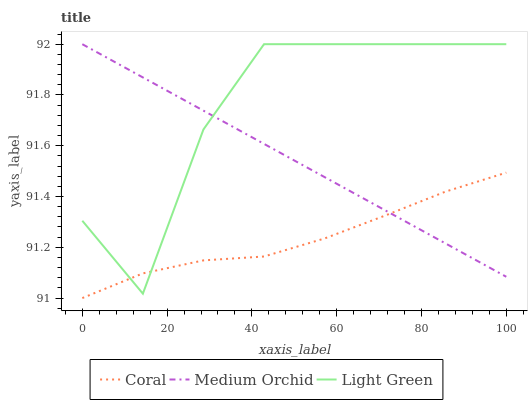Does Coral have the minimum area under the curve?
Answer yes or no. Yes. Does Light Green have the maximum area under the curve?
Answer yes or no. Yes. Does Medium Orchid have the minimum area under the curve?
Answer yes or no. No. Does Medium Orchid have the maximum area under the curve?
Answer yes or no. No. Is Medium Orchid the smoothest?
Answer yes or no. Yes. Is Light Green the roughest?
Answer yes or no. Yes. Is Light Green the smoothest?
Answer yes or no. No. Is Medium Orchid the roughest?
Answer yes or no. No. Does Coral have the lowest value?
Answer yes or no. Yes. Does Light Green have the lowest value?
Answer yes or no. No. Does Light Green have the highest value?
Answer yes or no. Yes. Does Medium Orchid intersect Light Green?
Answer yes or no. Yes. Is Medium Orchid less than Light Green?
Answer yes or no. No. Is Medium Orchid greater than Light Green?
Answer yes or no. No. 